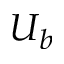<formula> <loc_0><loc_0><loc_500><loc_500>U _ { b }</formula> 